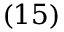<formula> <loc_0><loc_0><loc_500><loc_500>\left ( 1 5 \right )</formula> 